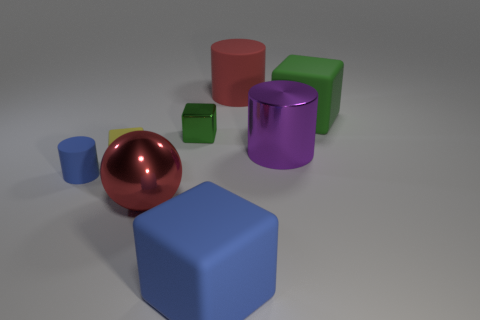Are the green object on the left side of the green rubber thing and the blue object to the right of the small matte cube made of the same material?
Your answer should be compact. No. There is a yellow cube; are there any big matte cubes on the left side of it?
Provide a short and direct response. No. What number of purple things are either metal cylinders or cylinders?
Offer a terse response. 1. Are the ball and the red thing that is to the right of the big blue object made of the same material?
Your answer should be compact. No. What size is the blue object that is the same shape as the small yellow thing?
Give a very brief answer. Large. What is the small green cube made of?
Give a very brief answer. Metal. The red thing in front of the cylinder that is left of the matte cylinder that is behind the tiny matte cylinder is made of what material?
Give a very brief answer. Metal. Is the size of the rubber cylinder that is behind the small yellow object the same as the blue rubber object on the left side of the small metal thing?
Offer a very short reply. No. How many other things are made of the same material as the big blue object?
Ensure brevity in your answer.  4. What number of rubber things are large brown blocks or small things?
Make the answer very short. 2. 